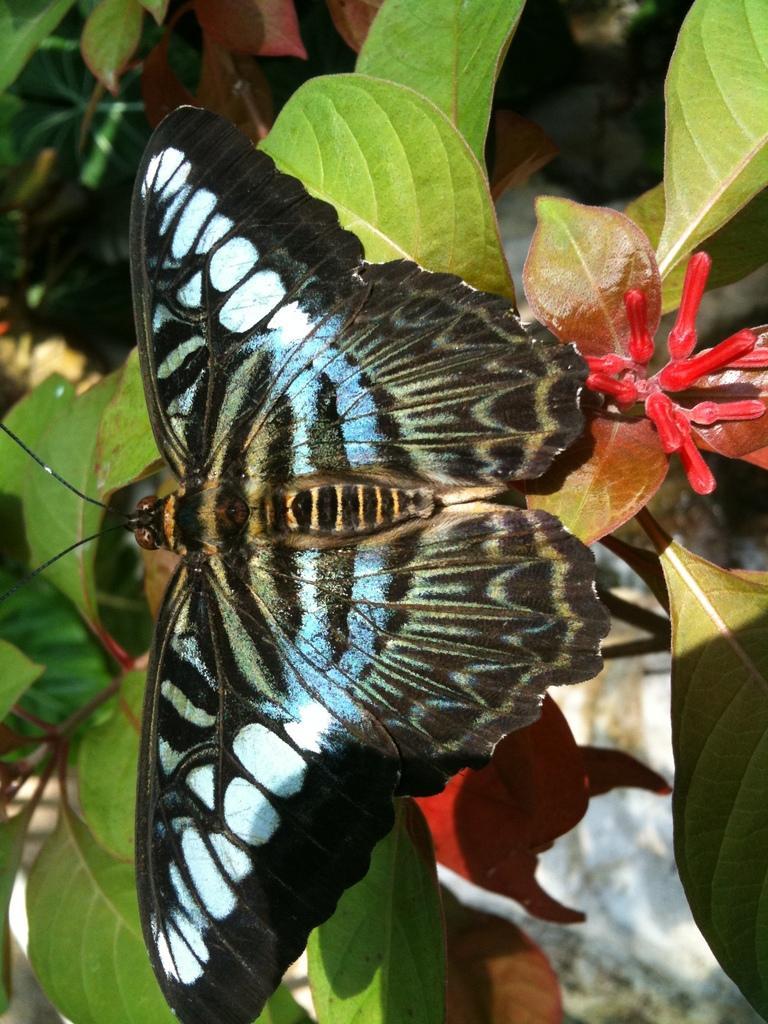In one or two sentences, can you explain what this image depicts? In this image, we can see some plants and a butterfly. 